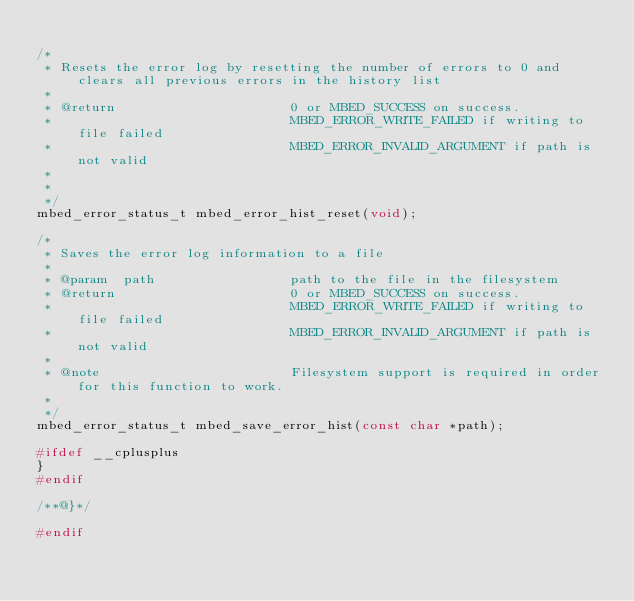Convert code to text. <code><loc_0><loc_0><loc_500><loc_500><_C_>
/*
 * Resets the error log by resetting the number of errors to 0 and clears all previous errors in the history list
 *
 * @return                      0 or MBED_SUCCESS on success.
 *                              MBED_ERROR_WRITE_FAILED if writing to file failed
 *                              MBED_ERROR_INVALID_ARGUMENT if path is not valid
 *
 *
 */
mbed_error_status_t mbed_error_hist_reset(void);

/*
 * Saves the error log information to a file
 *
 * @param  path                 path to the file in the filesystem
 * @return                      0 or MBED_SUCCESS on success.
 *                              MBED_ERROR_WRITE_FAILED if writing to file failed
 *                              MBED_ERROR_INVALID_ARGUMENT if path is not valid
 *
 * @note                        Filesystem support is required in order for this function to work.
 *
 */
mbed_error_status_t mbed_save_error_hist(const char *path);

#ifdef __cplusplus
}
#endif

/**@}*/

#endif
</code> 